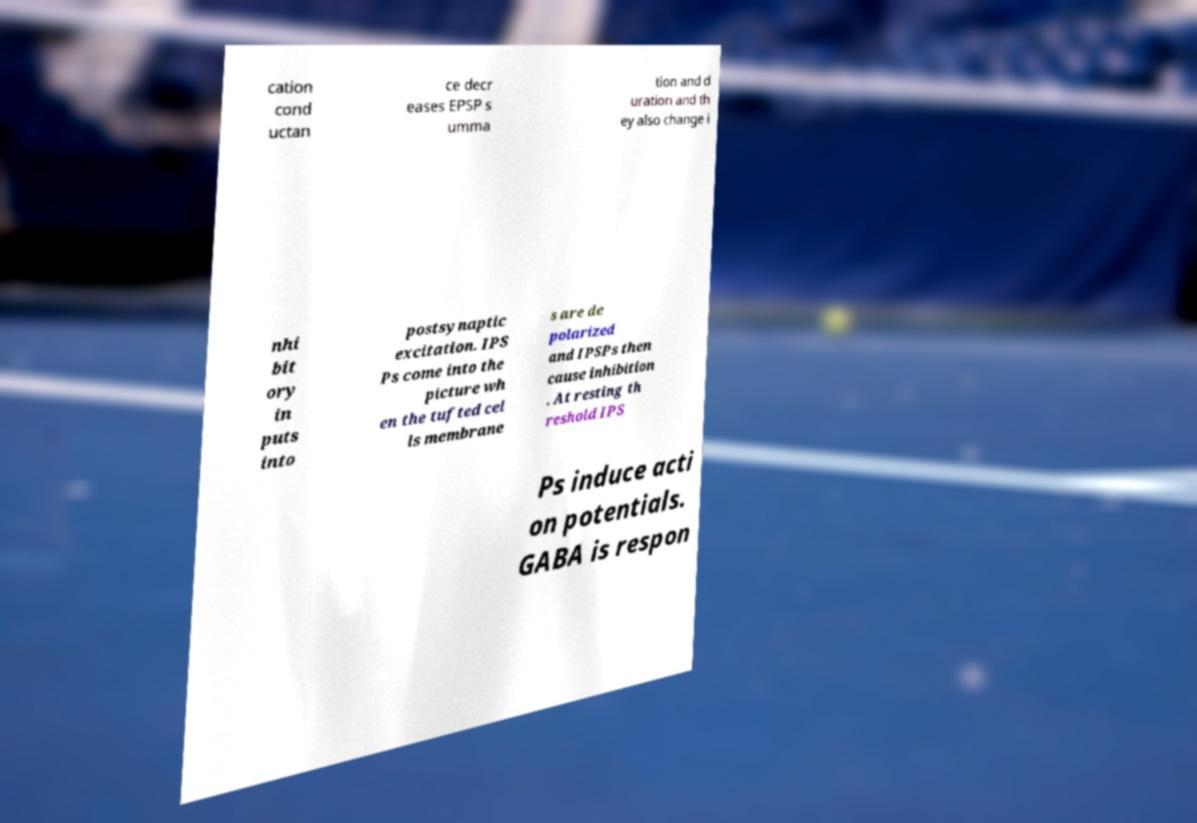For documentation purposes, I need the text within this image transcribed. Could you provide that? cation cond uctan ce decr eases EPSP s umma tion and d uration and th ey also change i nhi bit ory in puts into postsynaptic excitation. IPS Ps come into the picture wh en the tufted cel ls membrane s are de polarized and IPSPs then cause inhibition . At resting th reshold IPS Ps induce acti on potentials. GABA is respon 